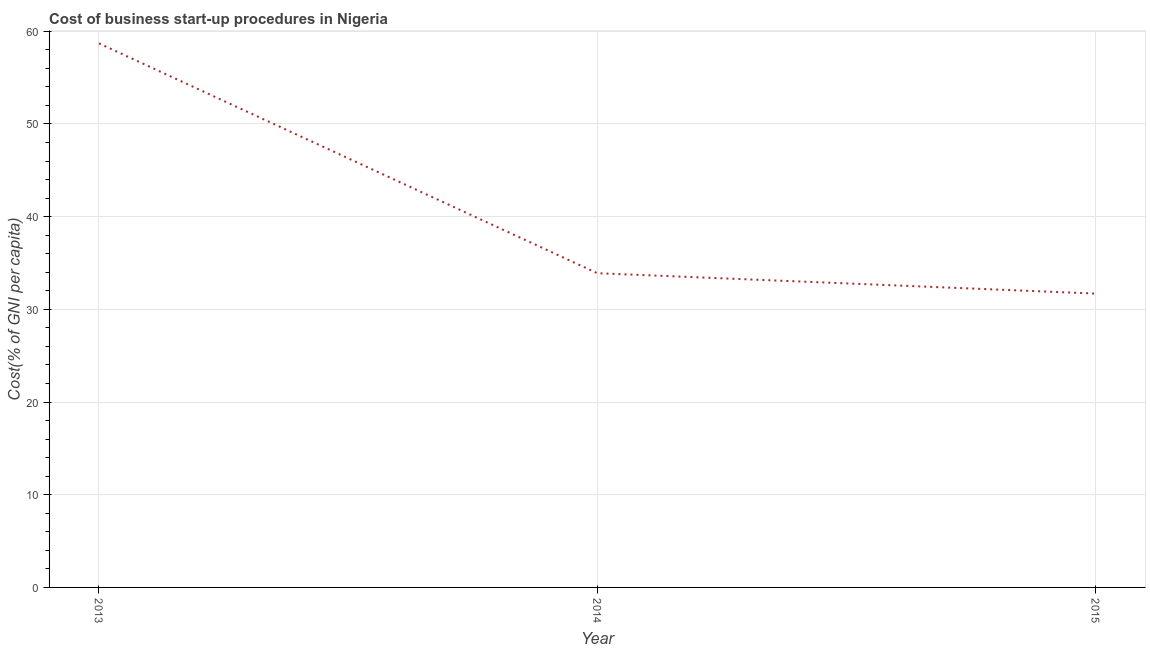What is the cost of business startup procedures in 2014?
Your answer should be very brief. 33.9. Across all years, what is the maximum cost of business startup procedures?
Provide a succinct answer. 58.7. Across all years, what is the minimum cost of business startup procedures?
Your response must be concise. 31.7. In which year was the cost of business startup procedures minimum?
Ensure brevity in your answer.  2015. What is the sum of the cost of business startup procedures?
Ensure brevity in your answer.  124.3. What is the difference between the cost of business startup procedures in 2014 and 2015?
Your answer should be compact. 2.2. What is the average cost of business startup procedures per year?
Offer a very short reply. 41.43. What is the median cost of business startup procedures?
Provide a short and direct response. 33.9. In how many years, is the cost of business startup procedures greater than 46 %?
Make the answer very short. 1. What is the ratio of the cost of business startup procedures in 2013 to that in 2015?
Offer a terse response. 1.85. Is the difference between the cost of business startup procedures in 2014 and 2015 greater than the difference between any two years?
Your response must be concise. No. What is the difference between the highest and the second highest cost of business startup procedures?
Ensure brevity in your answer.  24.8. What is the difference between the highest and the lowest cost of business startup procedures?
Keep it short and to the point. 27. In how many years, is the cost of business startup procedures greater than the average cost of business startup procedures taken over all years?
Ensure brevity in your answer.  1. Does the cost of business startup procedures monotonically increase over the years?
Provide a succinct answer. No. How many years are there in the graph?
Make the answer very short. 3. What is the difference between two consecutive major ticks on the Y-axis?
Keep it short and to the point. 10. Does the graph contain any zero values?
Offer a very short reply. No. Does the graph contain grids?
Make the answer very short. Yes. What is the title of the graph?
Your answer should be very brief. Cost of business start-up procedures in Nigeria. What is the label or title of the Y-axis?
Offer a very short reply. Cost(% of GNI per capita). What is the Cost(% of GNI per capita) of 2013?
Provide a short and direct response. 58.7. What is the Cost(% of GNI per capita) of 2014?
Offer a terse response. 33.9. What is the Cost(% of GNI per capita) of 2015?
Make the answer very short. 31.7. What is the difference between the Cost(% of GNI per capita) in 2013 and 2014?
Keep it short and to the point. 24.8. What is the difference between the Cost(% of GNI per capita) in 2013 and 2015?
Provide a short and direct response. 27. What is the difference between the Cost(% of GNI per capita) in 2014 and 2015?
Your answer should be compact. 2.2. What is the ratio of the Cost(% of GNI per capita) in 2013 to that in 2014?
Give a very brief answer. 1.73. What is the ratio of the Cost(% of GNI per capita) in 2013 to that in 2015?
Offer a terse response. 1.85. What is the ratio of the Cost(% of GNI per capita) in 2014 to that in 2015?
Your answer should be very brief. 1.07. 